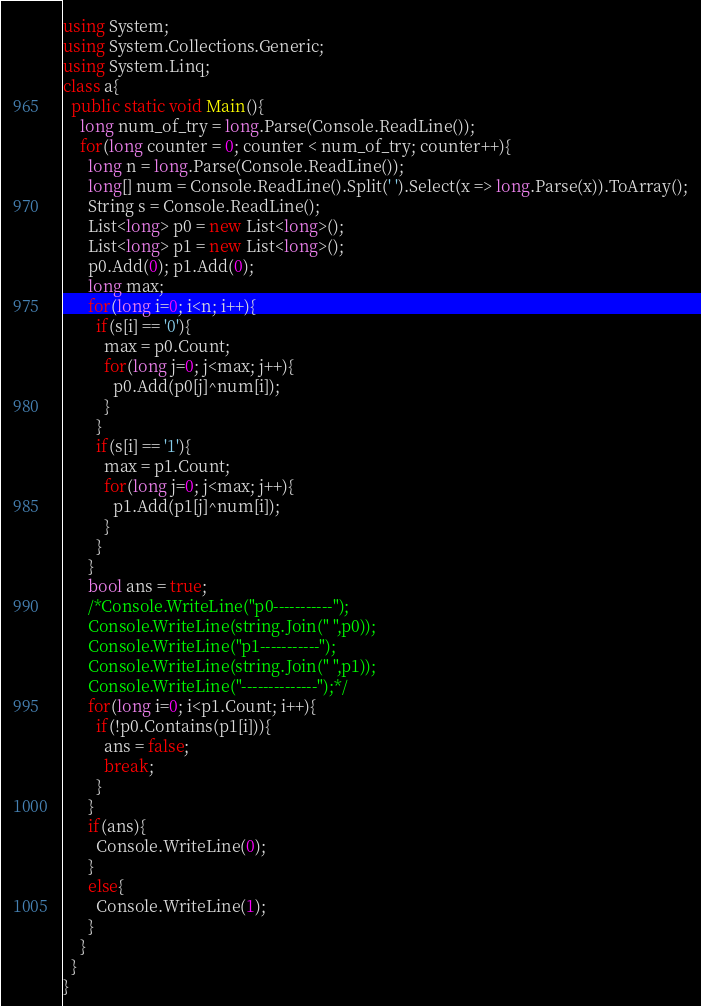Convert code to text. <code><loc_0><loc_0><loc_500><loc_500><_C#_>using System;
using System.Collections.Generic;
using System.Linq;
class a{
  public static void Main(){
    long num_of_try = long.Parse(Console.ReadLine());
    for(long counter = 0; counter < num_of_try; counter++){
      long n = long.Parse(Console.ReadLine());
      long[] num = Console.ReadLine().Split(' ').Select(x => long.Parse(x)).ToArray();
      String s = Console.ReadLine();
      List<long> p0 = new List<long>();
      List<long> p1 = new List<long>();
      p0.Add(0); p1.Add(0);
      long max;
      for(long i=0; i<n; i++){
        if(s[i] == '0'){
          max = p0.Count;
          for(long j=0; j<max; j++){
            p0.Add(p0[j]^num[i]);
          }
        }
        if(s[i] == '1'){
          max = p1.Count;
          for(long j=0; j<max; j++){
            p1.Add(p1[j]^num[i]);
          }
        }
      }
      bool ans = true;
      /*Console.WriteLine("p0-----------");
      Console.WriteLine(string.Join(" ",p0));
      Console.WriteLine("p1-----------");
      Console.WriteLine(string.Join(" ",p1));
      Console.WriteLine("--------------");*/
      for(long i=0; i<p1.Count; i++){
        if(!p0.Contains(p1[i])){
          ans = false;
          break;
        }
      }
      if(ans){
        Console.WriteLine(0);
      }
      else{
        Console.WriteLine(1);
      }
    }
  }
}
</code> 